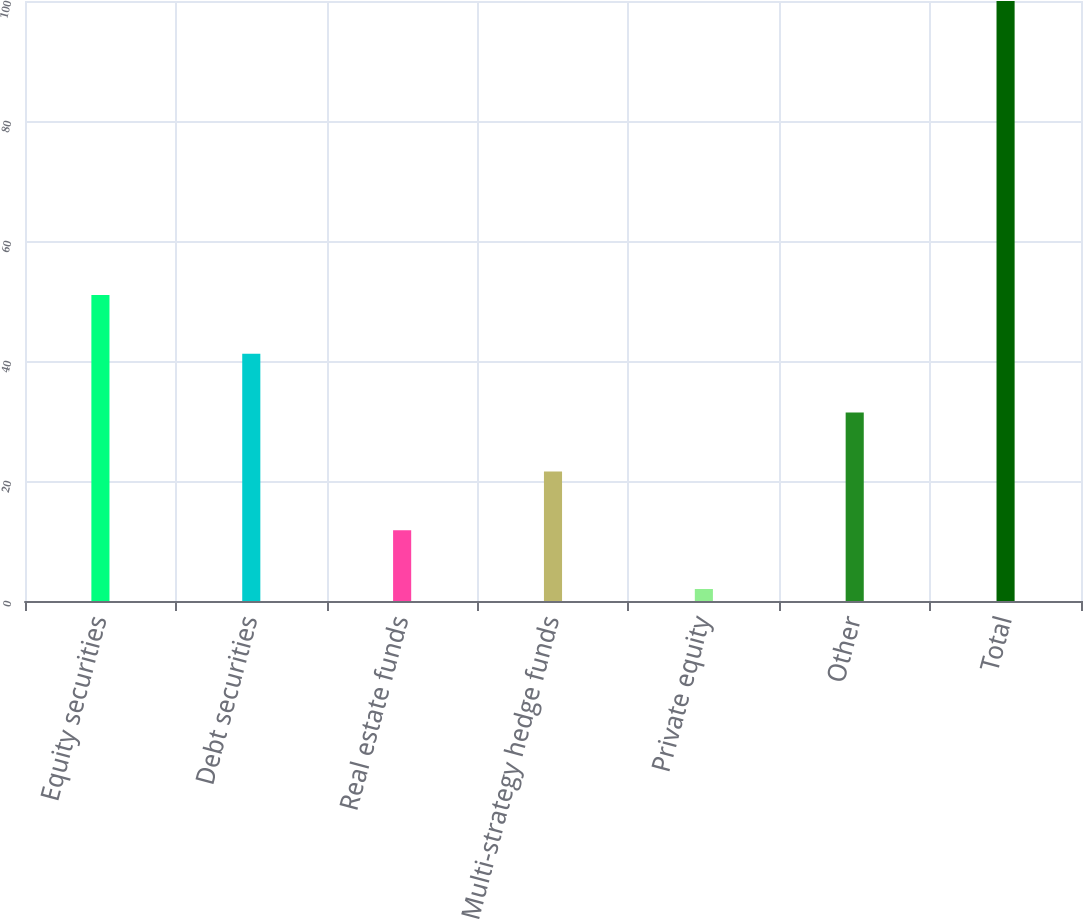Convert chart to OTSL. <chart><loc_0><loc_0><loc_500><loc_500><bar_chart><fcel>Equity securities<fcel>Debt securities<fcel>Real estate funds<fcel>Multi-strategy hedge funds<fcel>Private equity<fcel>Other<fcel>Total<nl><fcel>51<fcel>41.2<fcel>11.8<fcel>21.6<fcel>2<fcel>31.4<fcel>100<nl></chart> 